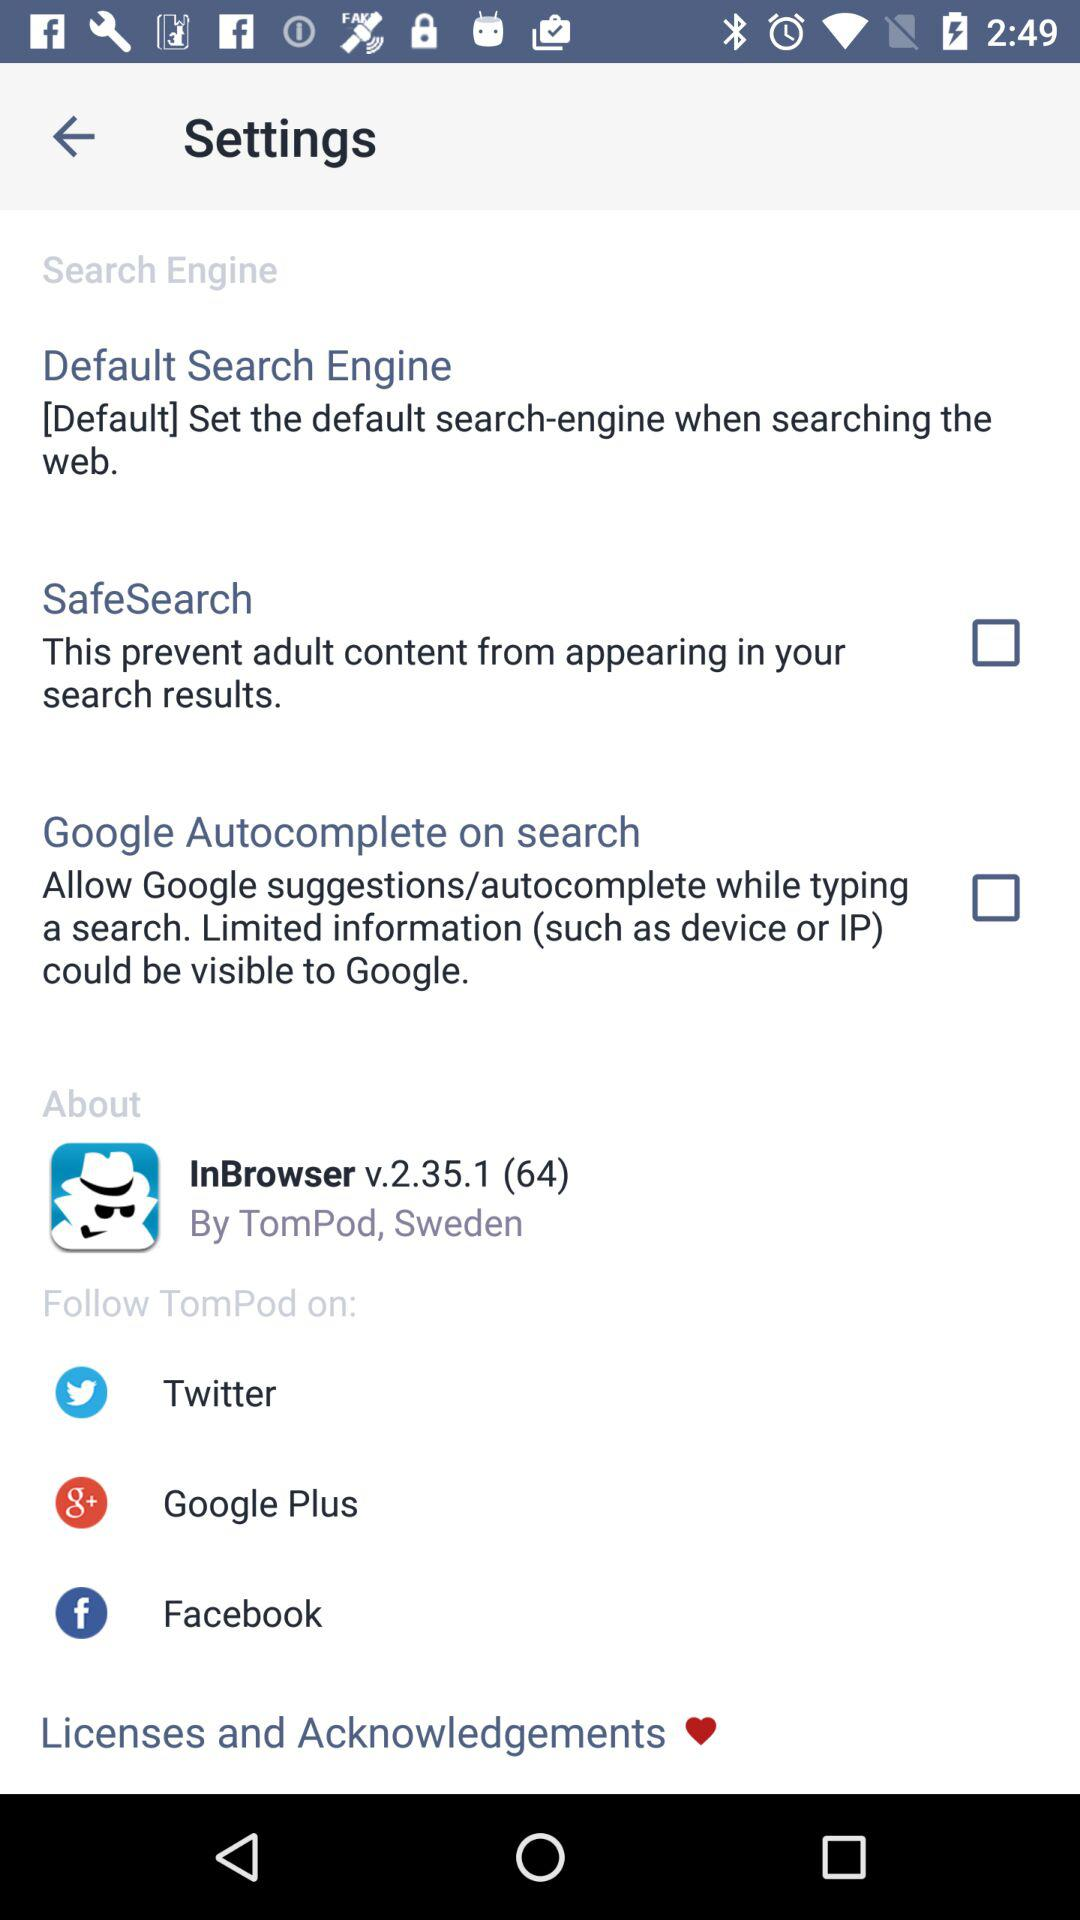What is the current status of the "SafeSearch" setting? The current status is "off". 